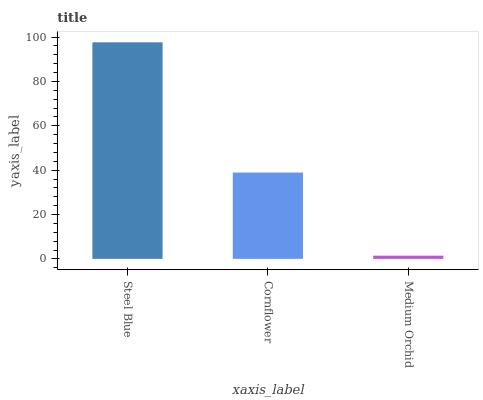Is Medium Orchid the minimum?
Answer yes or no. Yes. Is Steel Blue the maximum?
Answer yes or no. Yes. Is Cornflower the minimum?
Answer yes or no. No. Is Cornflower the maximum?
Answer yes or no. No. Is Steel Blue greater than Cornflower?
Answer yes or no. Yes. Is Cornflower less than Steel Blue?
Answer yes or no. Yes. Is Cornflower greater than Steel Blue?
Answer yes or no. No. Is Steel Blue less than Cornflower?
Answer yes or no. No. Is Cornflower the high median?
Answer yes or no. Yes. Is Cornflower the low median?
Answer yes or no. Yes. Is Steel Blue the high median?
Answer yes or no. No. Is Medium Orchid the low median?
Answer yes or no. No. 